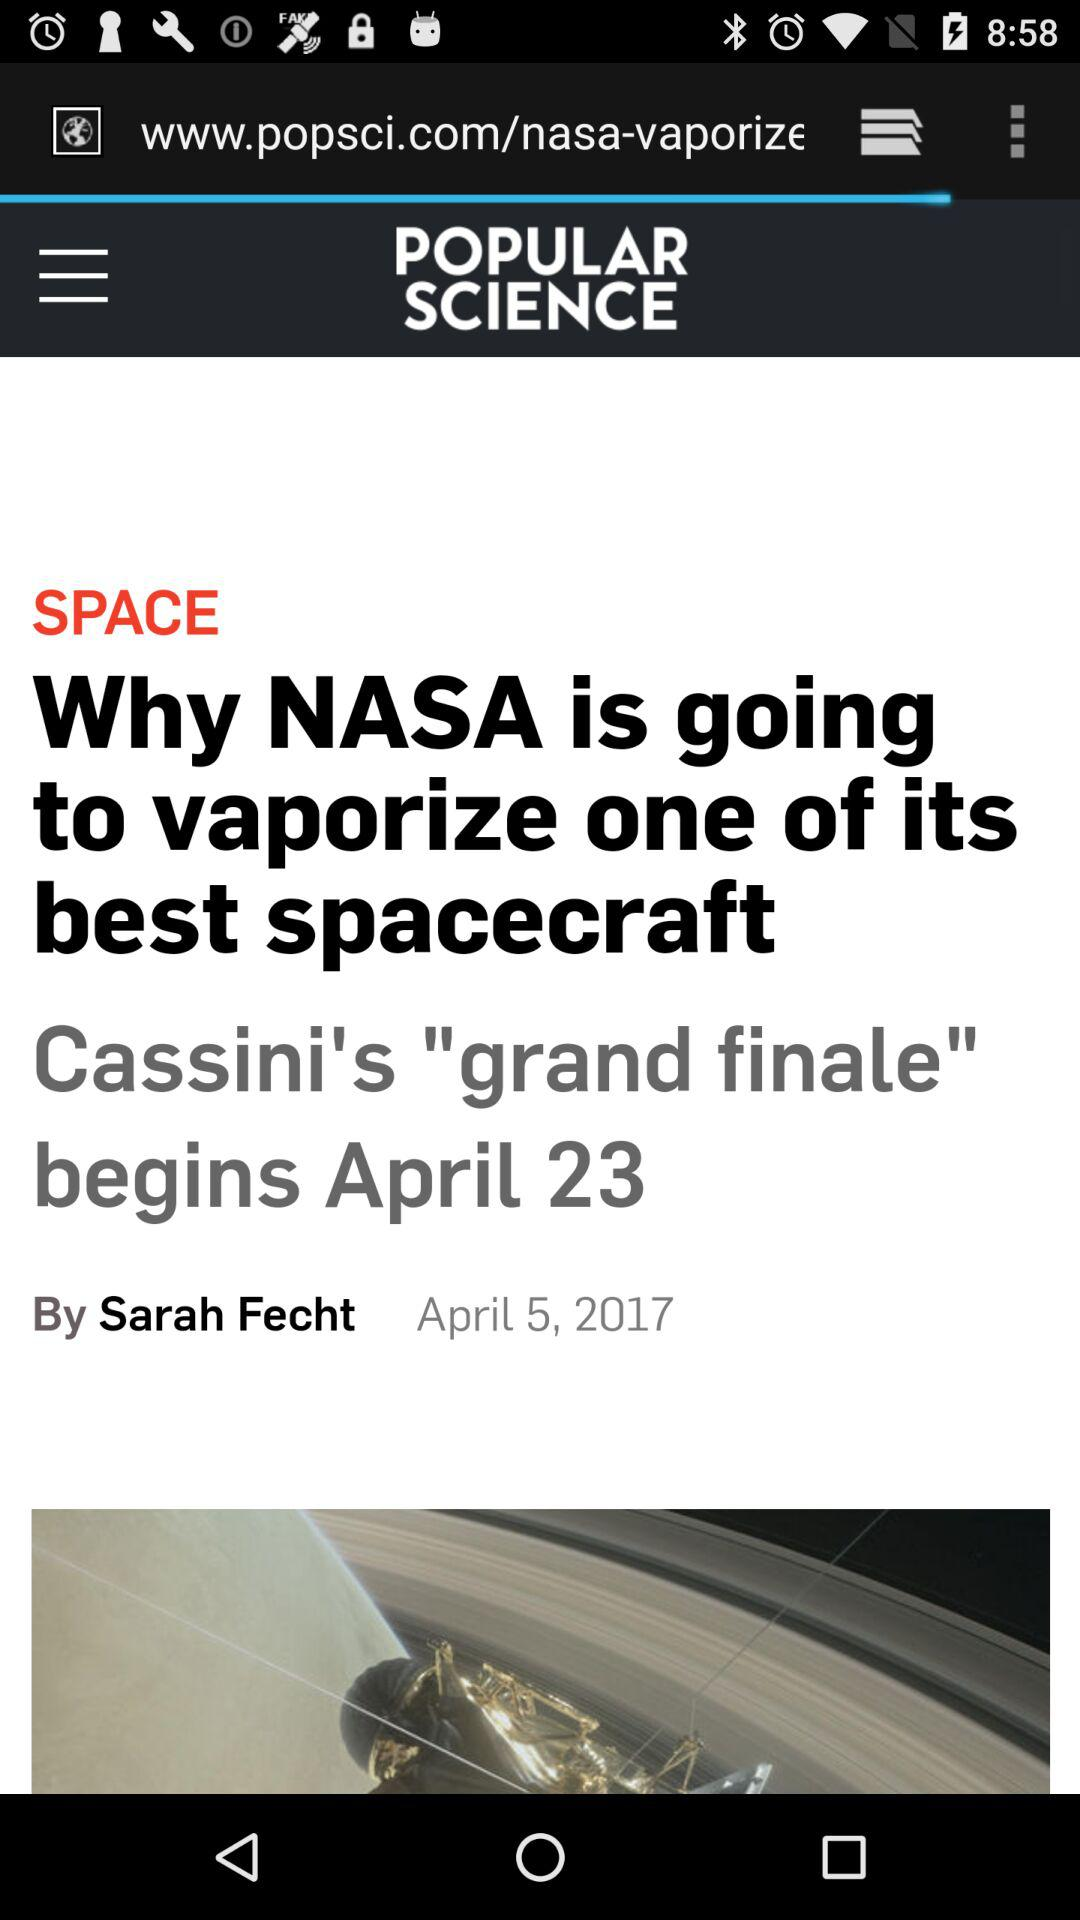On which date was the news "Why NASA is going to vaporize one of its best spacecraft" posted? The news was posted on April 5, 2017. 